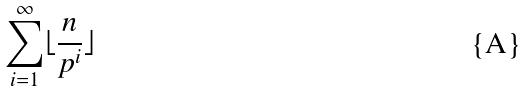Convert formula to latex. <formula><loc_0><loc_0><loc_500><loc_500>\sum _ { i = 1 } ^ { \infty } \lfloor \frac { n } { p ^ { i } } \rfloor</formula> 